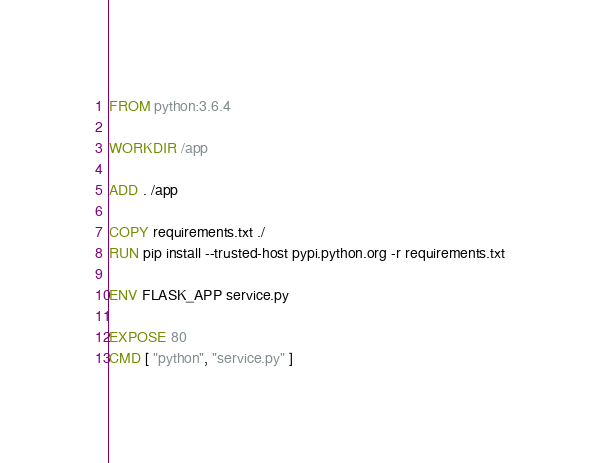Convert code to text. <code><loc_0><loc_0><loc_500><loc_500><_Dockerfile_>FROM python:3.6.4

WORKDIR /app

ADD . /app

COPY requirements.txt ./
RUN pip install --trusted-host pypi.python.org -r requirements.txt

ENV FLASK_APP service.py

EXPOSE 80
CMD [ "python", "service.py" ]
</code> 